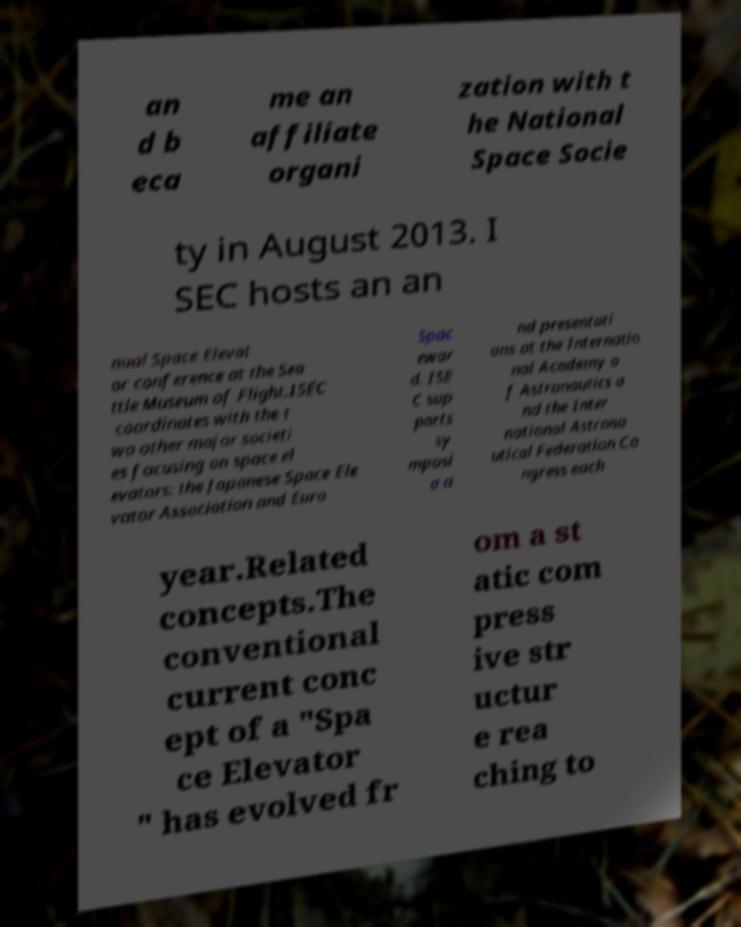Please read and relay the text visible in this image. What does it say? an d b eca me an affiliate organi zation with t he National Space Socie ty in August 2013. I SEC hosts an an nual Space Elevat or conference at the Sea ttle Museum of Flight.ISEC coordinates with the t wo other major societi es focusing on space el evators: the Japanese Space Ele vator Association and Euro Spac ewar d. ISE C sup ports sy mposi a a nd presentati ons at the Internatio nal Academy o f Astronautics a nd the Inter national Astrona utical Federation Co ngress each year.Related concepts.The conventional current conc ept of a "Spa ce Elevator " has evolved fr om a st atic com press ive str uctur e rea ching to 